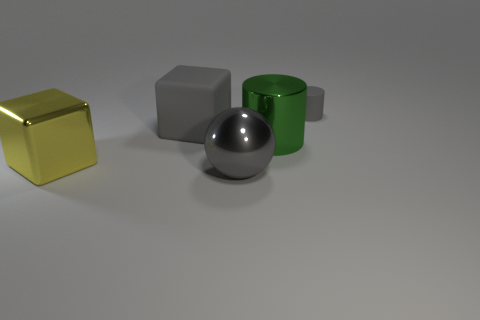Is the number of big matte objects that are behind the gray cylinder the same as the number of large gray metallic spheres? Yes, the number of large matte objects behind the gray cylinder, which is one matte gray cube, is the same as the number of large gray metallic spheres present, which is also one. 